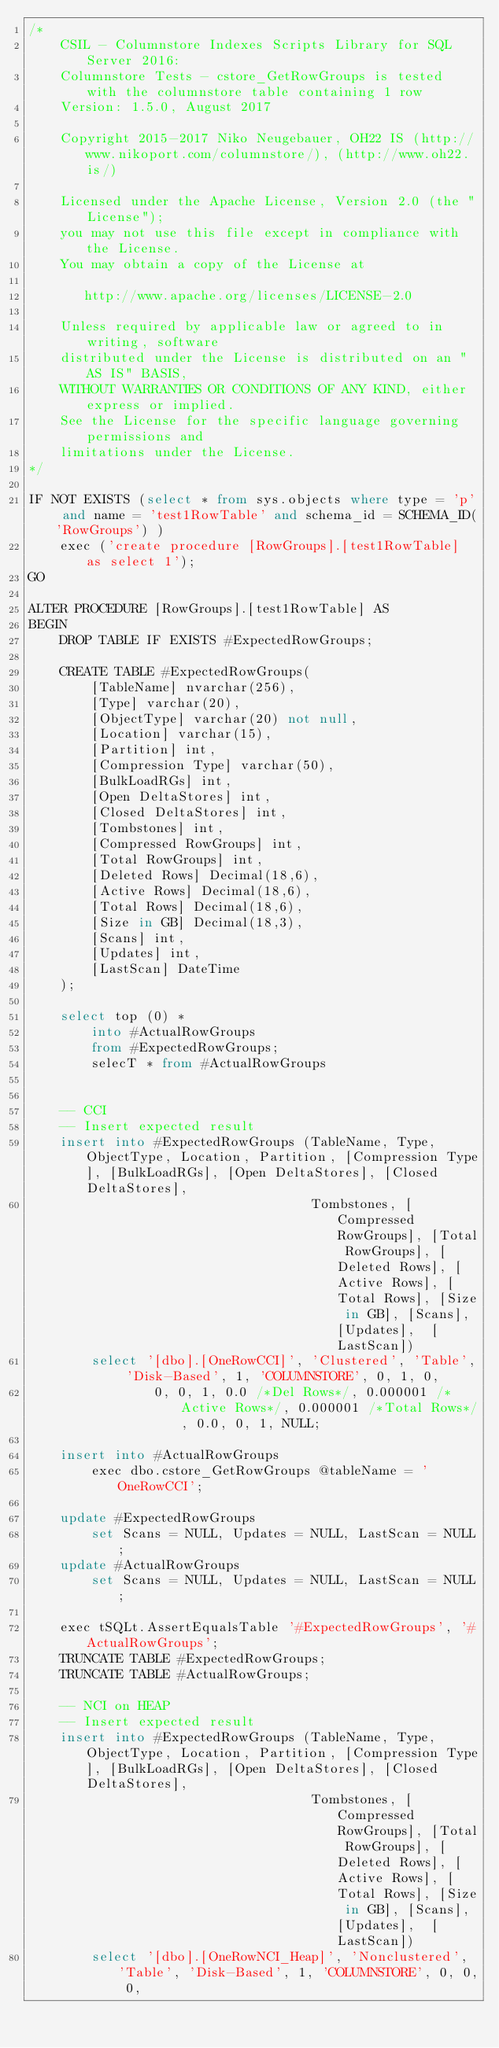Convert code to text. <code><loc_0><loc_0><loc_500><loc_500><_SQL_>/*
	CSIL - Columnstore Indexes Scripts Library for SQL Server 2016: 
	Columnstore Tests - cstore_GetRowGroups is tested with the columnstore table containing 1 row
	Version: 1.5.0, August 2017

	Copyright 2015-2017 Niko Neugebauer, OH22 IS (http://www.nikoport.com/columnstore/), (http://www.oh22.is/)

	Licensed under the Apache License, Version 2.0 (the "License");
	you may not use this file except in compliance with the License.
	You may obtain a copy of the License at

       http://www.apache.org/licenses/LICENSE-2.0

    Unless required by applicable law or agreed to in writing, software
    distributed under the License is distributed on an "AS IS" BASIS,
    WITHOUT WARRANTIES OR CONDITIONS OF ANY KIND, either express or implied.
    See the License for the specific language governing permissions and
    limitations under the License.
*/

IF NOT EXISTS (select * from sys.objects where type = 'p' and name = 'test1RowTable' and schema_id = SCHEMA_ID('RowGroups') )
	exec ('create procedure [RowGroups].[test1RowTable] as select 1');
GO

ALTER PROCEDURE [RowGroups].[test1RowTable] AS
BEGIN
	DROP TABLE IF EXISTS #ExpectedRowGroups;

	CREATE TABLE #ExpectedRowGroups(
		[TableName] nvarchar(256),
		[Type] varchar(20),
		[ObjectType] varchar(20) not null,
		[Location] varchar(15),
		[Partition] int,
		[Compression Type] varchar(50),
		[BulkLoadRGs] int,
		[Open DeltaStores] int,
		[Closed DeltaStores] int,
		[Tombstones] int,
		[Compressed RowGroups] int,
		[Total RowGroups] int,
		[Deleted Rows] Decimal(18,6),
		[Active Rows] Decimal(18,6),
		[Total Rows] Decimal(18,6),
		[Size in GB] Decimal(18,3),
		[Scans] int,
		[Updates] int,
		[LastScan] DateTime
	);

	select top (0) *
		into #ActualRowGroups
		from #ExpectedRowGroups;
		selecT * from #ActualRowGroups


	-- CCI
	-- Insert expected result
	insert into #ExpectedRowGroups (TableName, Type, ObjectType, Location, Partition, [Compression Type], [BulkLoadRGs], [Open DeltaStores], [Closed DeltaStores],
									Tombstones, [Compressed RowGroups], [Total RowGroups], [Deleted Rows], [Active Rows], [Total Rows], [Size in GB], [Scans], [Updates],  [LastScan])
		select '[dbo].[OneRowCCI]', 'Clustered', 'Table', 'Disk-Based', 1, 'COLUMNSTORE', 0, 1, 0, 
				0, 0, 1, 0.0 /*Del Rows*/, 0.000001 /*Active Rows*/, 0.000001 /*Total Rows*/, 0.0, 0, 1, NULL;

	insert into #ActualRowGroups
		exec dbo.cstore_GetRowGroups @tableName = 'OneRowCCI';

	update #ExpectedRowGroups
		set Scans = NULL, Updates = NULL, LastScan = NULL;
	update #ActualRowGroups
		set Scans = NULL, Updates = NULL, LastScan = NULL;

	exec tSQLt.AssertEqualsTable '#ExpectedRowGroups', '#ActualRowGroups';
	TRUNCATE TABLE #ExpectedRowGroups;
	TRUNCATE TABLE #ActualRowGroups;

	-- NCI on HEAP
	-- Insert expected result
	insert into #ExpectedRowGroups (TableName, Type, ObjectType, Location, Partition, [Compression Type], [BulkLoadRGs], [Open DeltaStores], [Closed DeltaStores],
									Tombstones, [Compressed RowGroups], [Total RowGroups], [Deleted Rows], [Active Rows], [Total Rows], [Size in GB], [Scans], [Updates],  [LastScan])
		select '[dbo].[OneRowNCI_Heap]', 'Nonclustered', 'Table', 'Disk-Based', 1, 'COLUMNSTORE', 0, 0, 0, </code> 